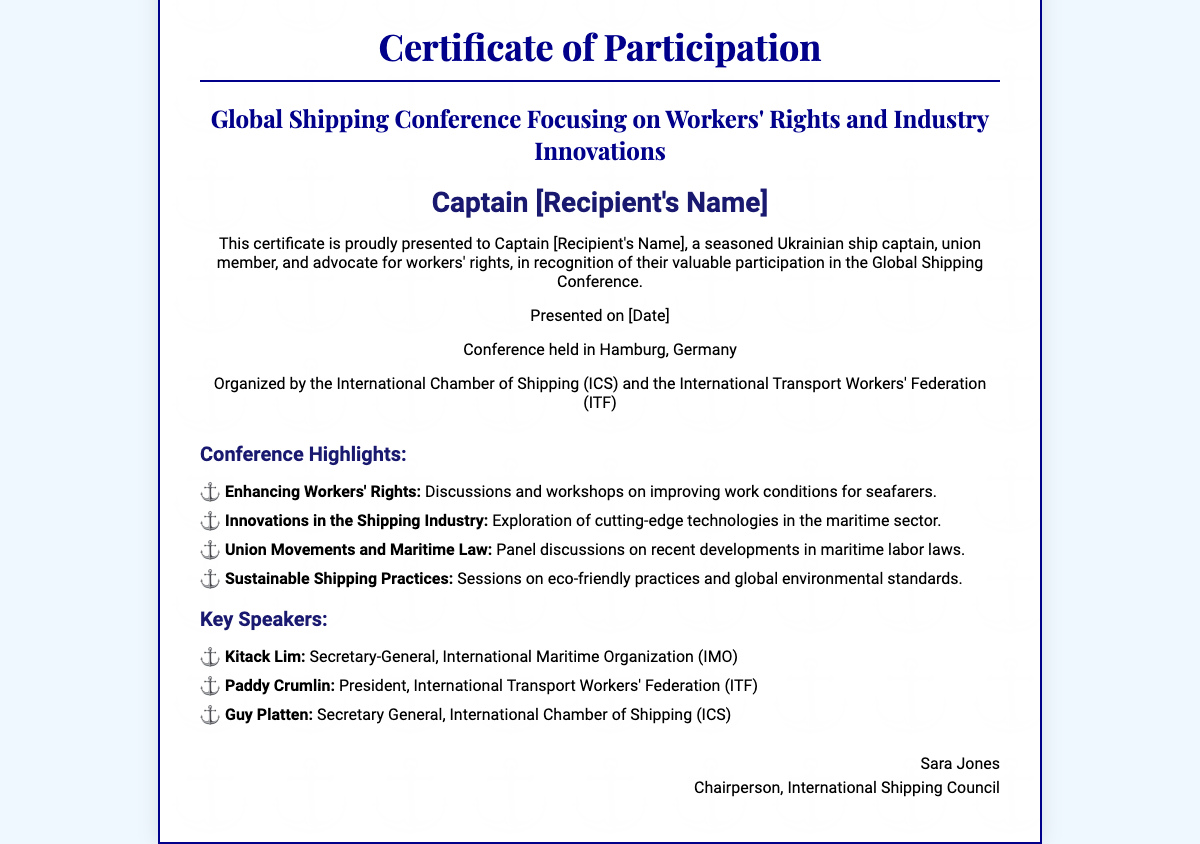What is the title of the conference? The title of the conference is provided prominently in the document, stating its focus and nature.
Answer: Global Shipping Conference Focusing on Workers' Rights and Industry Innovations Who is the recipient of the certificate? The recipient's name is highlighted in the certificate as an acknowledgment of their participation.
Answer: Captain [Recipient's Name] When was the certificate presented? The date on the document indicates when the certificate was given to the recipient.
Answer: [Date] Where was the conference held? The location of the conference is specified clearly within the document.
Answer: Hamburg, Germany Who organized the conference? The organizing bodies mentioned in the document are responsible for the event's execution.
Answer: International Chamber of Shipping (ICS) and the International Transport Workers' Federation (ITF) What is one of the conference highlights? The document lists several highlights, pointing to discussions and themes covered during the conference.
Answer: Enhancing Workers' Rights Name a key speaker from the conference. The document includes a list of notable speakers, indicating their roles and affiliations.
Answer: Kitack Lim What is the position of Sara Jones? The signature section of the document provides information about the individual's role within the organizing body.
Answer: Chairperson How many highlights are listed in the document? A review of the highlights section reveals the total number of distinct highlights mentioned.
Answer: Four 